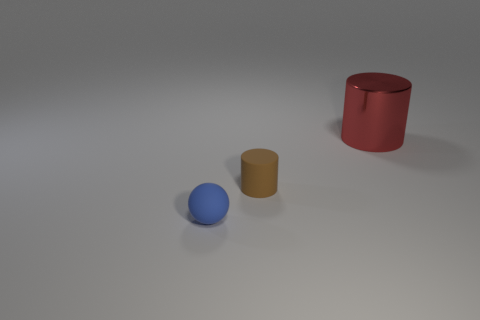Add 3 brown things. How many objects exist? 6 Subtract all balls. How many objects are left? 2 Add 1 green spheres. How many green spheres exist? 1 Subtract 0 purple cubes. How many objects are left? 3 Subtract all blue matte cylinders. Subtract all tiny brown cylinders. How many objects are left? 2 Add 2 brown cylinders. How many brown cylinders are left? 3 